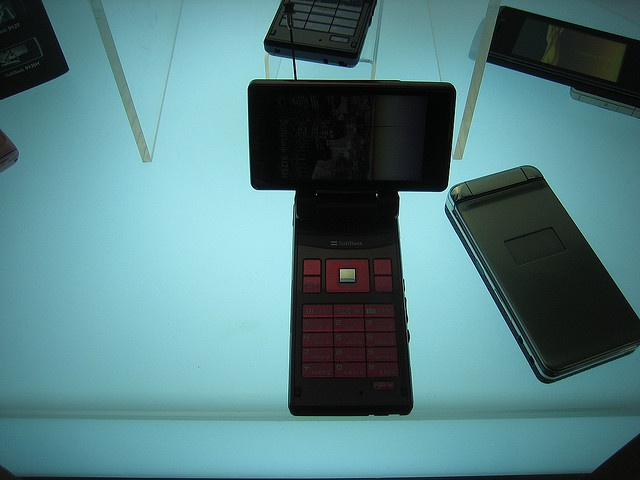Describe the objects in this image and their specific colors. I can see cell phone in black, maroon, teal, and lightblue tones, cell phone in black, darkgreen, and teal tones, cell phone in black, teal, and darkgreen tones, and cell phone in black, purple, and darkblue tones in this image. 